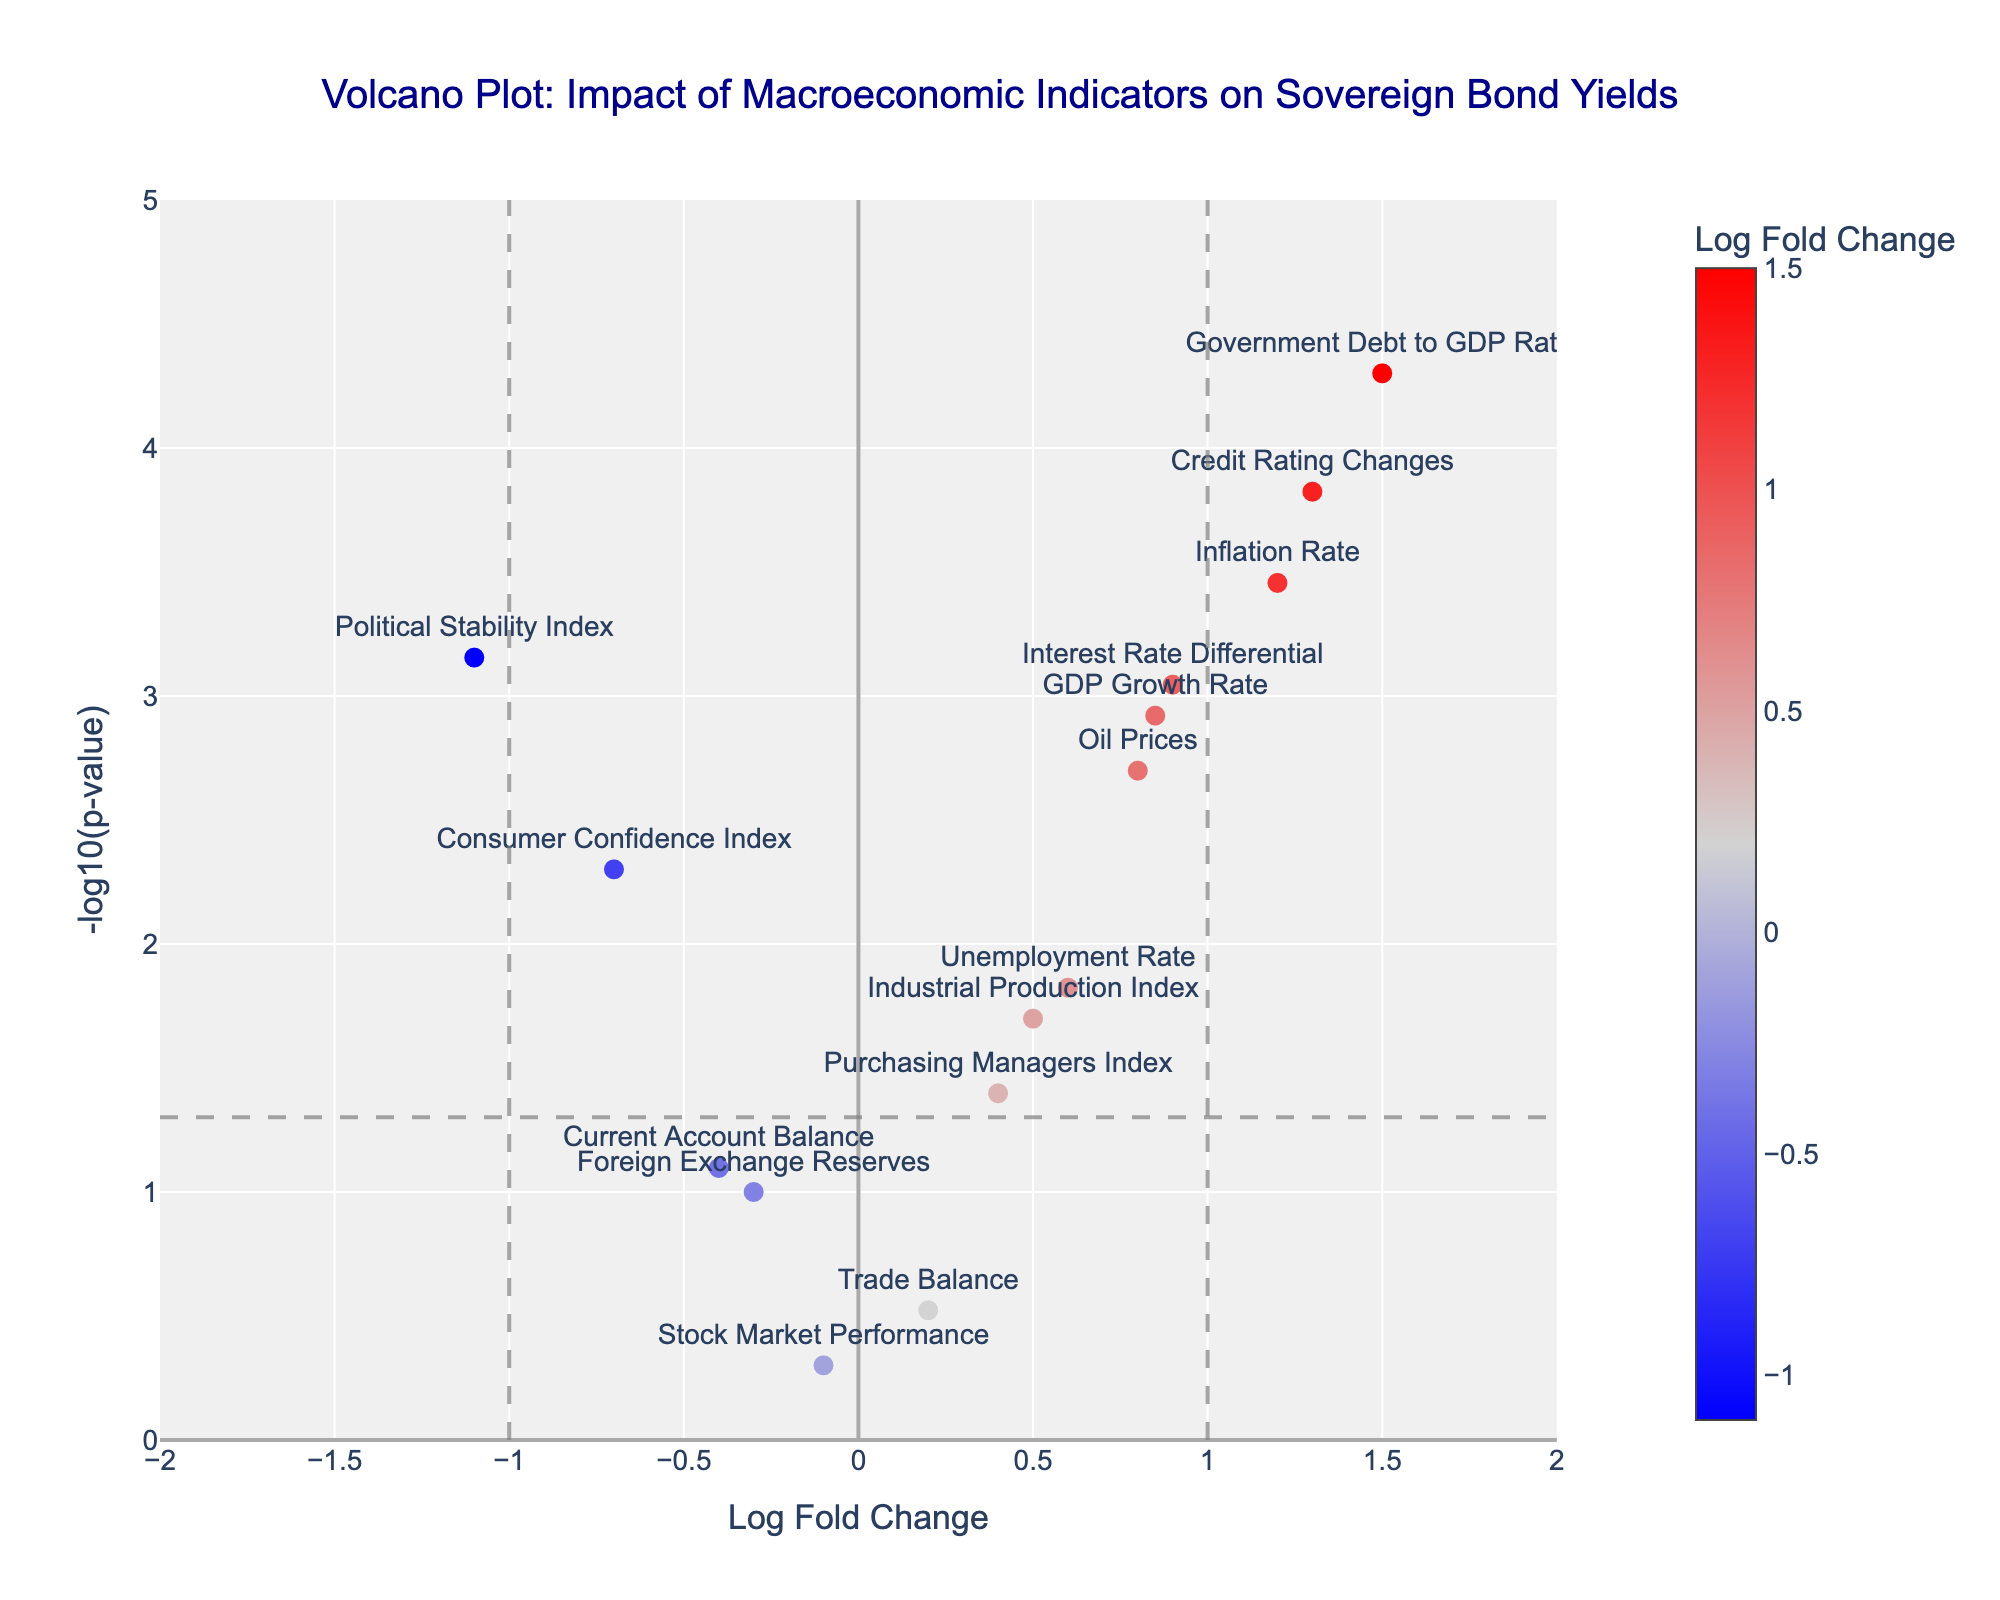Which indicator has the highest Log Fold Change (LogFC)? To determine the indicator with the highest LogFC, we need to find the data point farthest to the right. The "Government Debt to GDP Ratio" has the highest LogFC of 1.5.
Answer: Government Debt to GDP Ratio How many indicators have a p-value less than 0.05? The dashed horizontal line at -log10(0.05) helps identify these indicators. We count the data points above this threshold line. There are 10 such indicators.
Answer: 10 Which indicator has the lowest p-value? The indicator with the highest -log10(p-value) corresponds to the lowest p-value. The "Government Debt to GDP Ratio" has the highest -log10(p-value), making it the indicator with the lowest p-value.
Answer: Government Debt to GDP Ratio Which indicators are considered significant and have a negative impact on sovereign bond yields? Significant indicators are those above the threshold line (-log10(0.05)), and a negative impact means their LogFC is less than 0. The "Political Stability Index" and "Consumer Confidence Index" meet these criteria.
Answer: Political Stability Index, Consumer Confidence Index Between "GDP Growth Rate" and "Inflation Rate," which indicator has a more significant impact on sovereign bond yields? Significance is indicated by the p-value; the lower the p-value, the more significant the impact. "Inflation Rate" has a lower p-value (0.00035) compared to "GDP Growth Rate" (0.0012).
Answer: Inflation Rate What is the range of Log Fold Change (LogFC) values in the plot? To find the range, we look at the smallest and largest LogFC values. The smallest is for "Political Stability Index" (-1.1) and the largest for "Government Debt to GDP Ratio" (1.5). So the range is from -1.1 to 1.5.
Answer: -1.1 to 1.5 Which indicator is closest to the threshold line for significance but isn't considered significant? The indicator just below the threshold line of -log10(0.05) is not considered significant. The "Current Account Balance," with a p-value of 0.08, is near this line.
Answer: Current Account Balance How does "Oil Prices" compare to "Industrial Production Index" in terms of LogFC and p-values? "Oil Prices" have a higher LogFC (0.8 vs. 0.5) and a lower p-value (0.002 vs. 0.02) than the "Industrial Production Index," indicating a stronger and more significant impact.
Answer: Oil Prices has higher LogFC and lower p-value What does the color represent in the plot? The color scale represents the Log Fold Change (LogFC) values, with blue for negative, light gray for near zero, and red for positive values.
Answer: Log Fold Change Which indicator has a significant positive impact and is closest to the significance threshold? Among the significant indicators above the threshold line, the "Industrial Production Index" has the smallest positive LogFC (0.5), making it the closest to the threshold while still being significant.
Answer: Industrial Production Index 